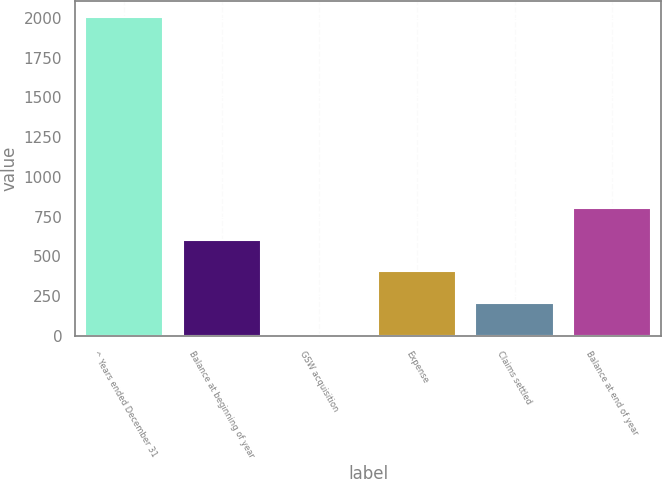Convert chart. <chart><loc_0><loc_0><loc_500><loc_500><bar_chart><fcel>^ Years ended December 31<fcel>Balance at beginning of year<fcel>GSW acquisition<fcel>Expense<fcel>Claims settled<fcel>Balance at end of year<nl><fcel>2007<fcel>605.6<fcel>5<fcel>405.4<fcel>205.2<fcel>805.8<nl></chart> 